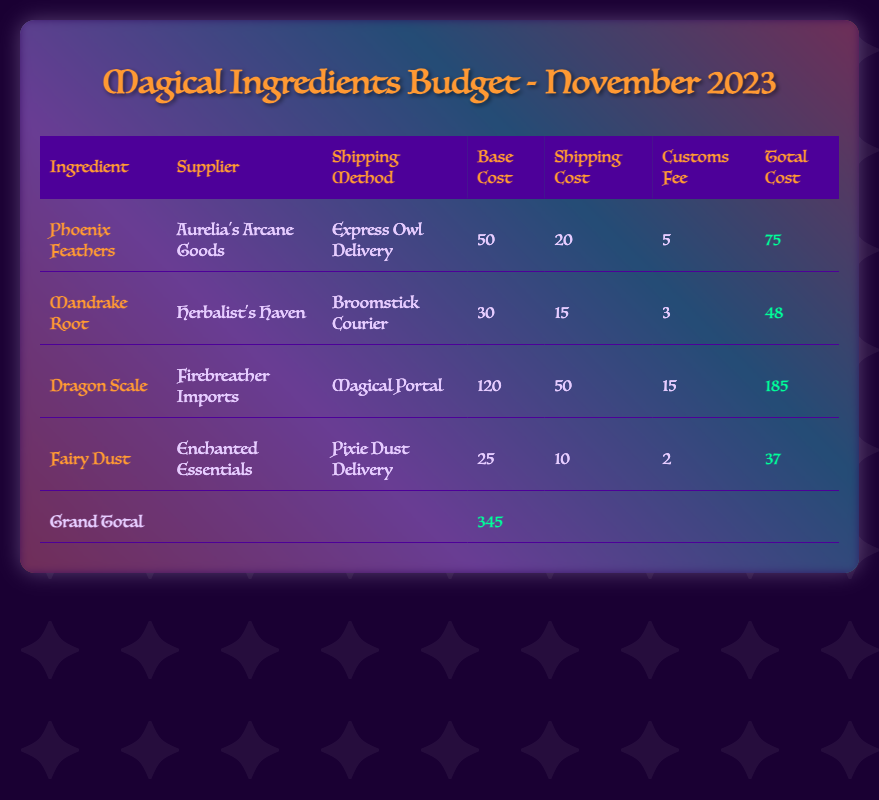What is the shipping cost for Phoenix Feathers? The shipping cost for Phoenix Feathers is listed in the table under the 'Shipping Cost' column.
Answer: 20 Who is the supplier of Dragon Scale? The supplier of Dragon Scale is provided in the table under the 'Supplier' column.
Answer: Firebreather Imports What is the total cost of Mandrake Root? The total cost for Mandrake Root can be found in the 'Total Cost' column of the table.
Answer: 48 What is the customs fee for Fairy Dust? The customs fee for Fairy Dust is specified in the table in the 'Customs Fee' column.
Answer: 2 Which shipping method is used for Dragon Scale? The shipping method for Dragon Scale is indicated in the 'Shipping Method' column of the table.
Answer: Magical Portal How much did the entire budget for November 2023 total? The grand total is calculated from the total costs of all the ingredients listed in the table's footer.
Answer: 345 What is the base cost of Phoenix Feathers? The base cost of Phoenix Feathers can be found in the 'Base Cost' column of the table.
Answer: 50 Which ingredient has the highest total cost? The ingredient with the highest total cost is determined by comparing all 'Total Cost' values in the table.
Answer: Dragon Scale What is the shipping method for Fairy Dust? The shipping method for Fairy Dust is listed in the 'Shipping Method' column.
Answer: Pixie Dust Delivery What is the shipping cost for Dragon Scale? The shipping cost for Dragon Scale is provided in the 'Shipping Cost' column of the table.
Answer: 50 